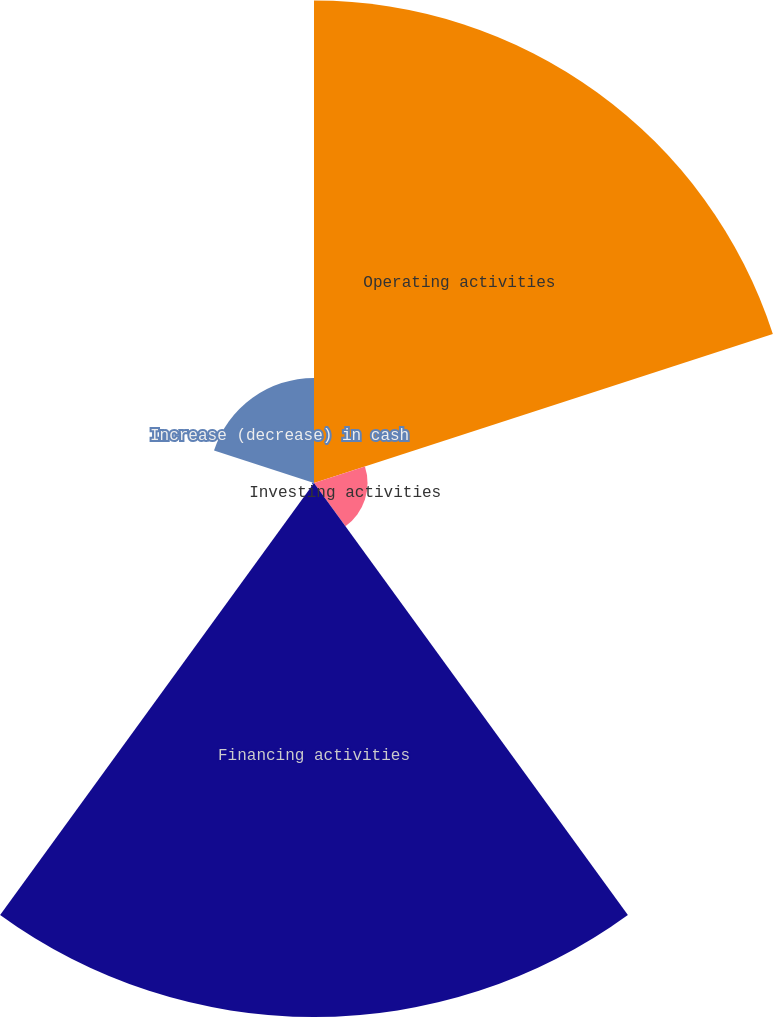Convert chart to OTSL. <chart><loc_0><loc_0><loc_500><loc_500><pie_chart><fcel>Operating activities<fcel>Investing activities<fcel>Financing activities<fcel>Effect of exchange rate<fcel>Increase (decrease) in cash<nl><fcel>40.99%<fcel>4.55%<fcel>45.37%<fcel>0.17%<fcel>8.93%<nl></chart> 